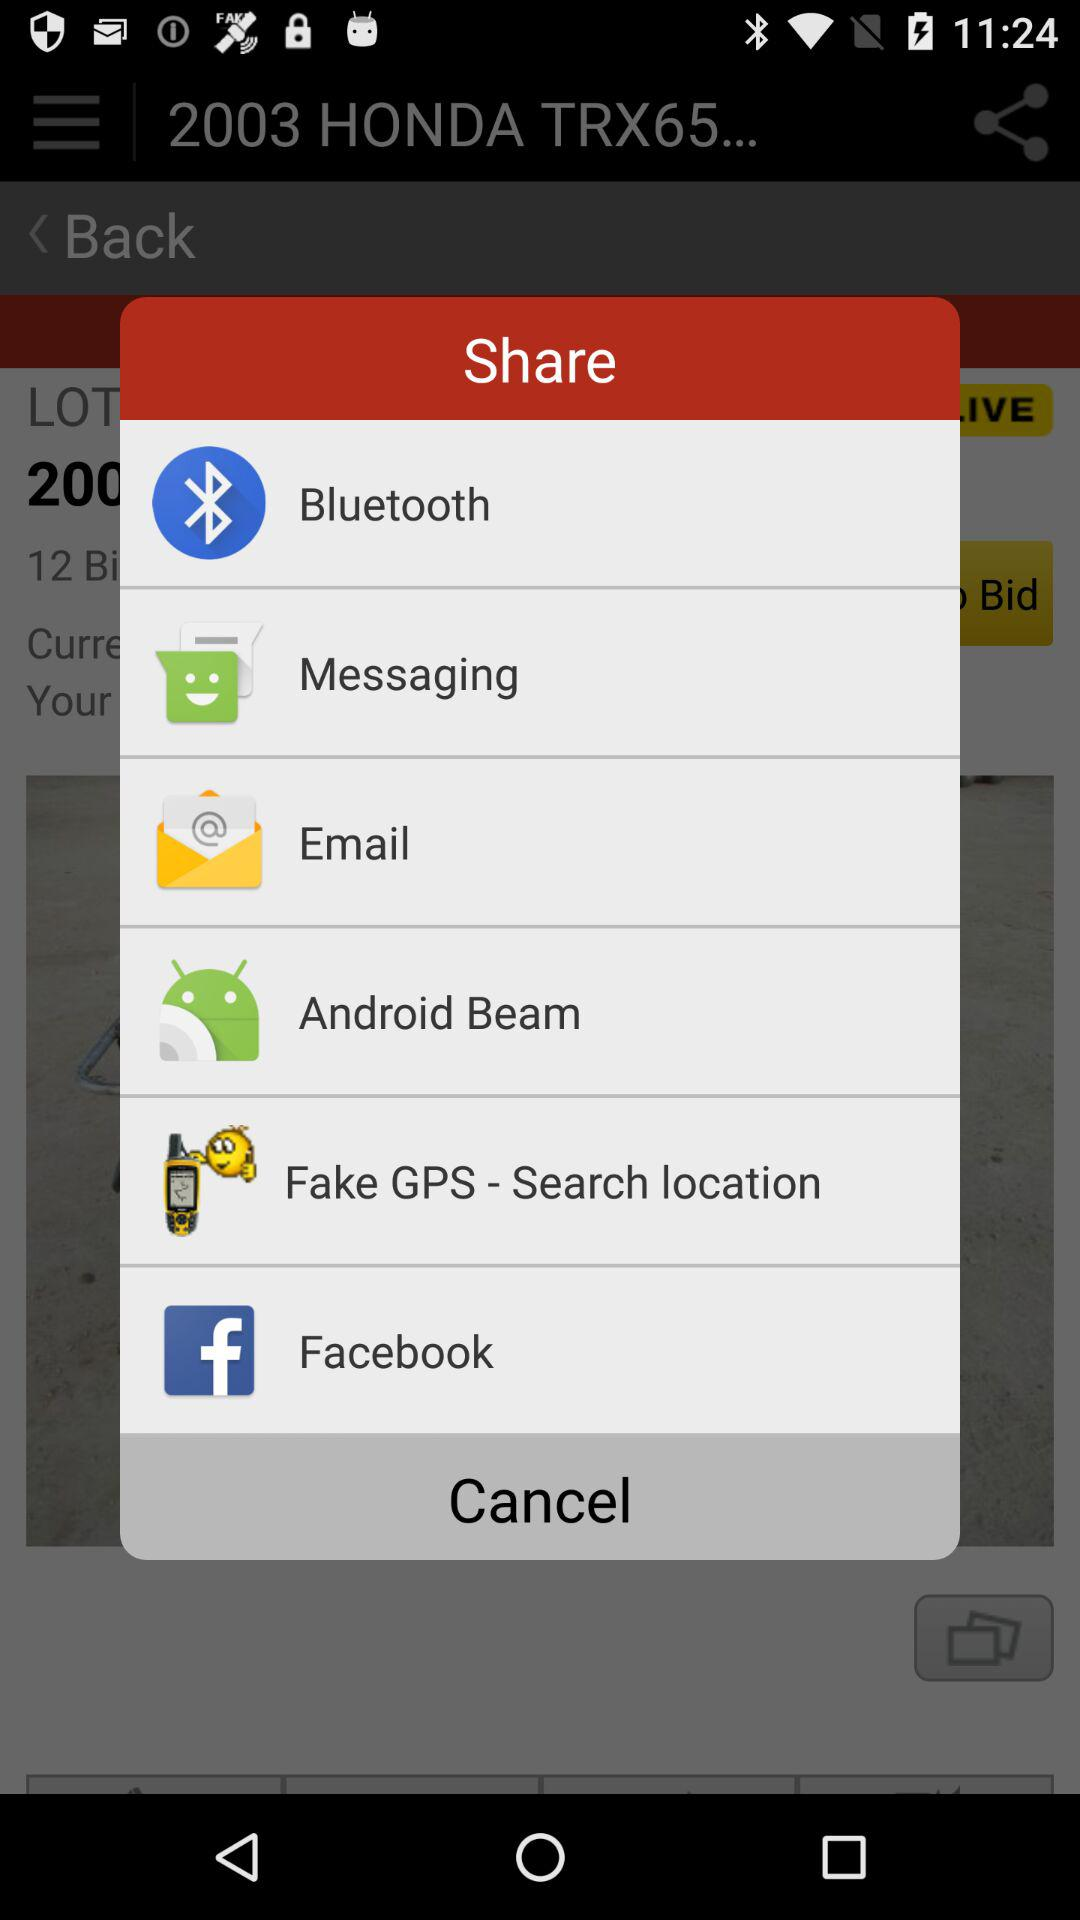How many items does the share menu have?
Answer the question using a single word or phrase. 6 